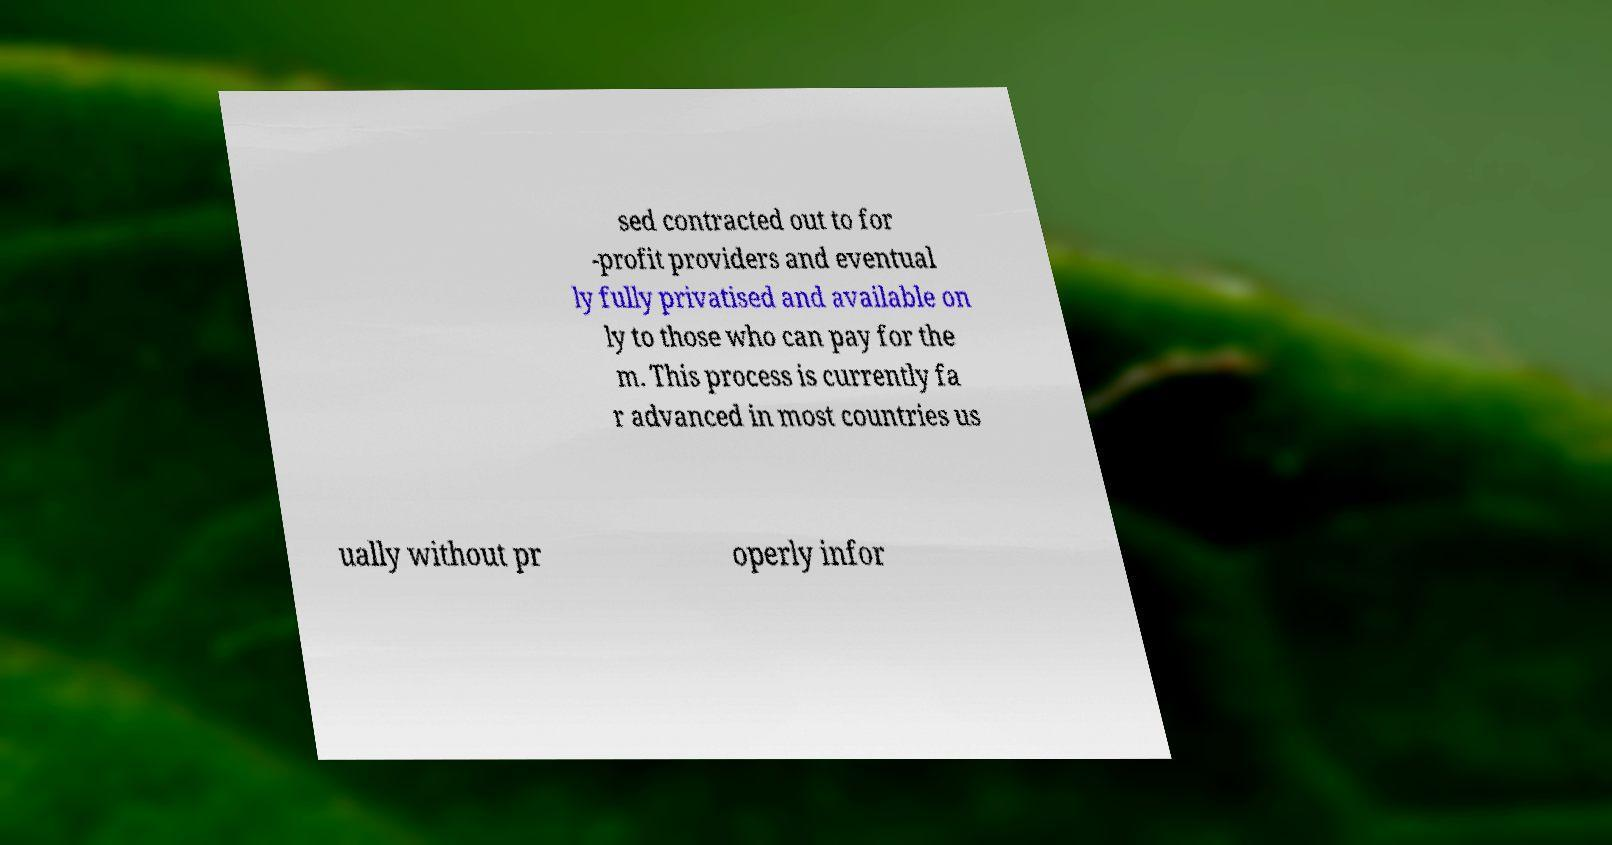Can you accurately transcribe the text from the provided image for me? sed contracted out to for -profit providers and eventual ly fully privatised and available on ly to those who can pay for the m. This process is currently fa r advanced in most countries us ually without pr operly infor 